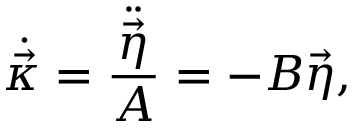Convert formula to latex. <formula><loc_0><loc_0><loc_500><loc_500>\dot { \vec { \kappa } } = \frac { \ddot { \vec { \eta } } } { A } = - B \vec { \eta } ,</formula> 